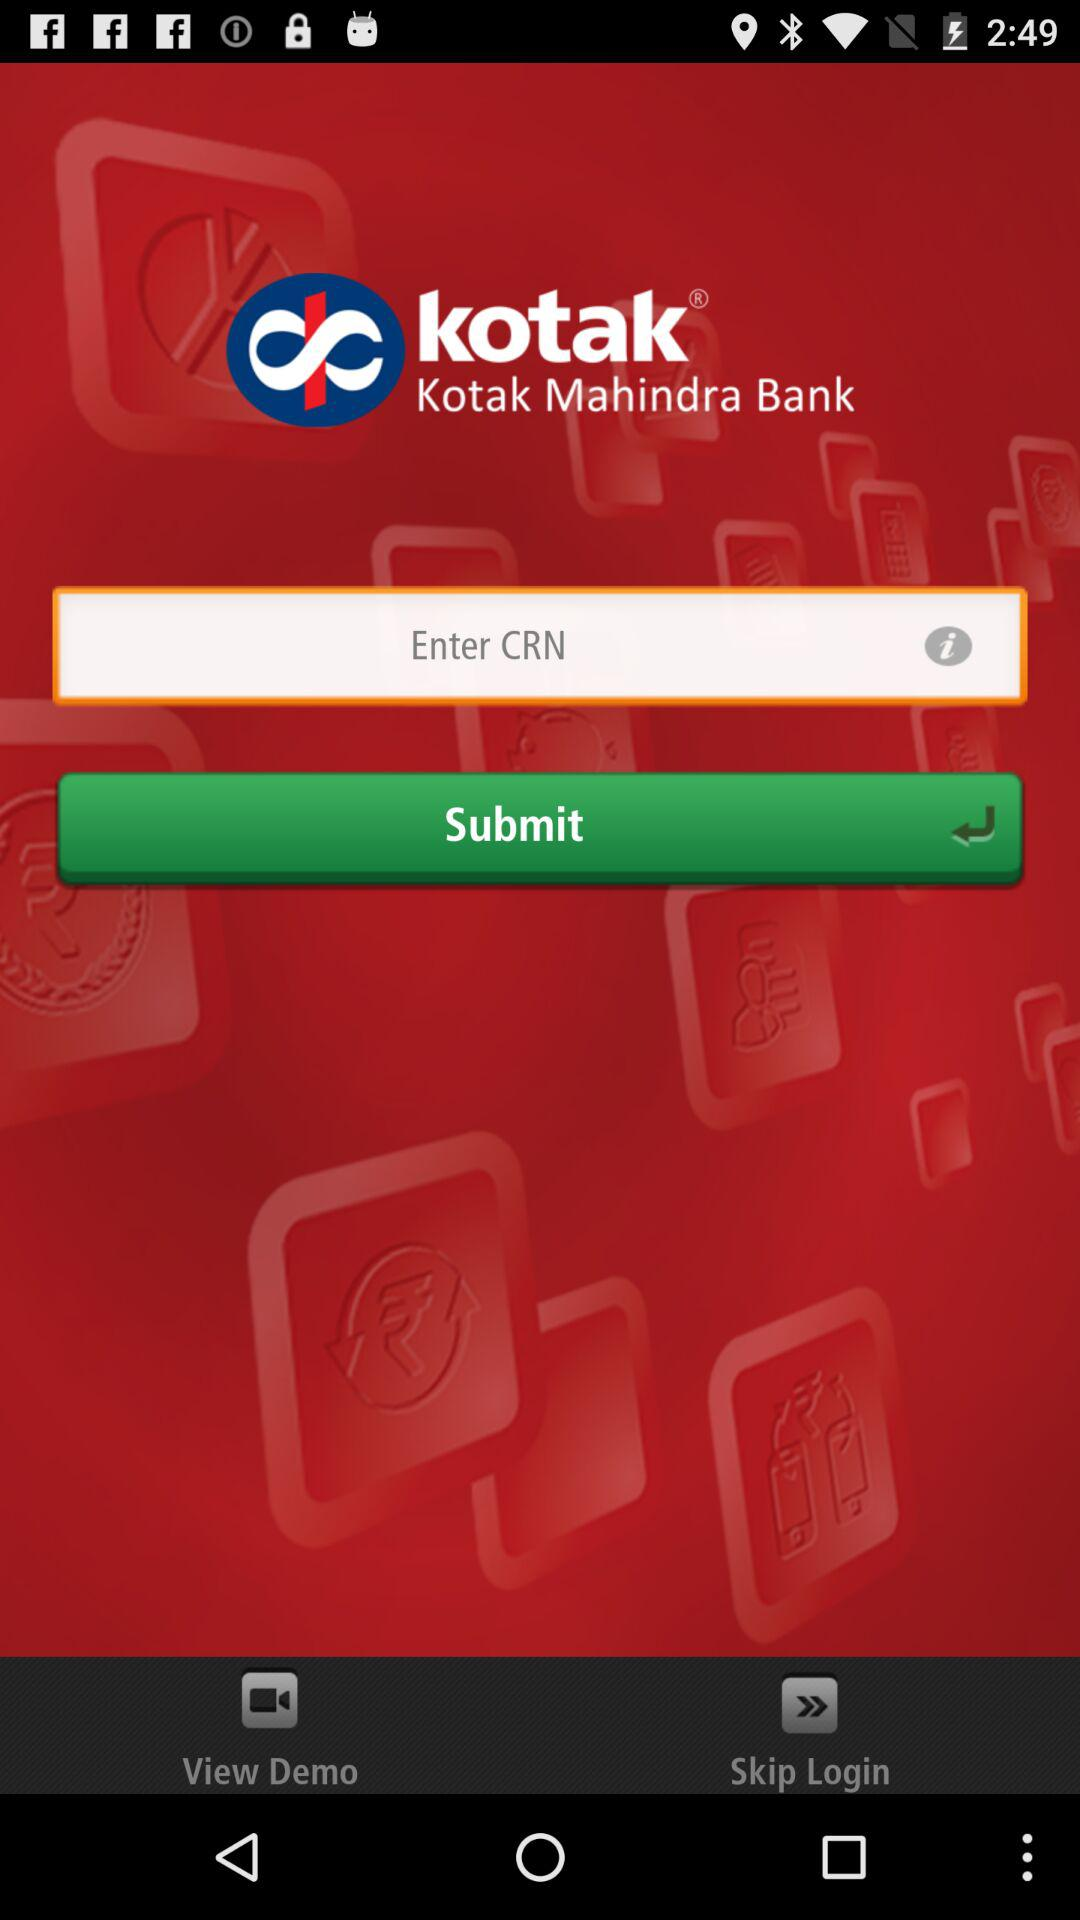What is the name of the application? The name of the application is "kotak". 